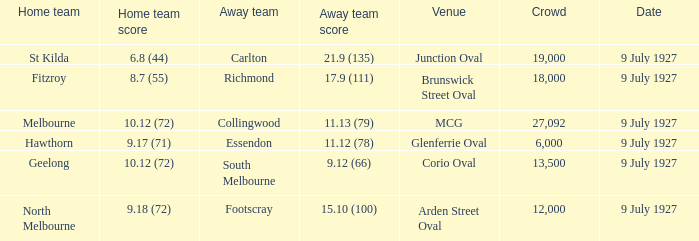What was the largest crowd where the home team was Fitzroy? 18000.0. 